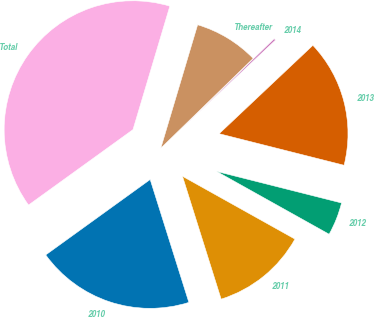<chart> <loc_0><loc_0><loc_500><loc_500><pie_chart><fcel>2010<fcel>2011<fcel>2012<fcel>2013<fcel>2014<fcel>Thereafter<fcel>Total<nl><fcel>19.9%<fcel>12.04%<fcel>4.17%<fcel>15.97%<fcel>0.24%<fcel>8.11%<fcel>39.57%<nl></chart> 